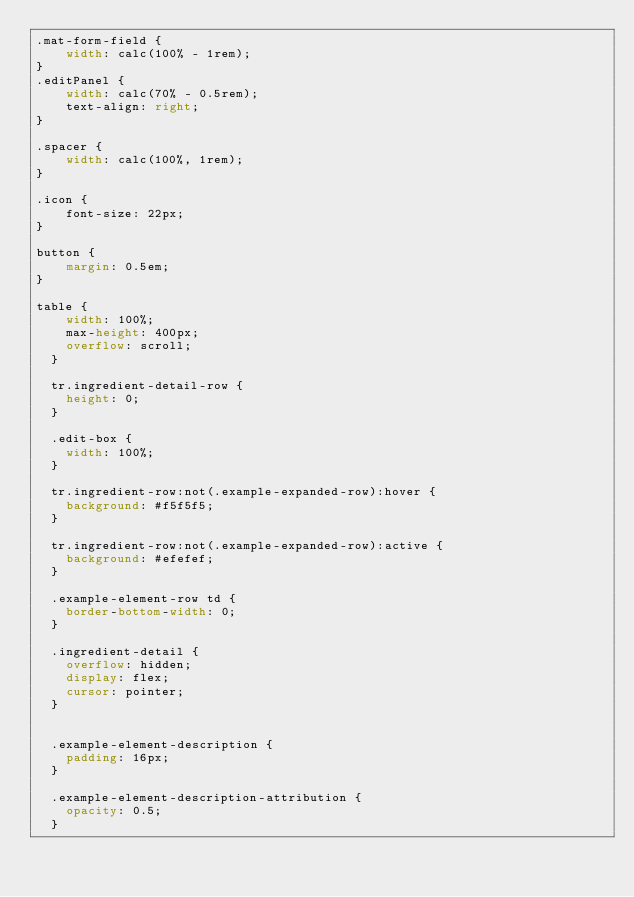Convert code to text. <code><loc_0><loc_0><loc_500><loc_500><_CSS_>.mat-form-field {
    width: calc(100% - 1rem);
}
.editPanel {
    width: calc(70% - 0.5rem);
    text-align: right;
}

.spacer {
    width: calc(100%, 1rem);
}

.icon {
    font-size: 22px;
}

button {
    margin: 0.5em;
}

table {
    width: 100%;
    max-height: 400px;
    overflow: scroll;
  }

  tr.ingredient-detail-row {
    height: 0;
  }

  .edit-box {
    width: 100%;
  }

  tr.ingredient-row:not(.example-expanded-row):hover {
    background: #f5f5f5;
  }

  tr.ingredient-row:not(.example-expanded-row):active {
    background: #efefef;
  }

  .example-element-row td {
    border-bottom-width: 0;
  }

  .ingredient-detail {
    overflow: hidden;
    display: flex;
    cursor: pointer;
  }


  .example-element-description {
    padding: 16px;
  }

  .example-element-description-attribution {
    opacity: 0.5;
  }
</code> 